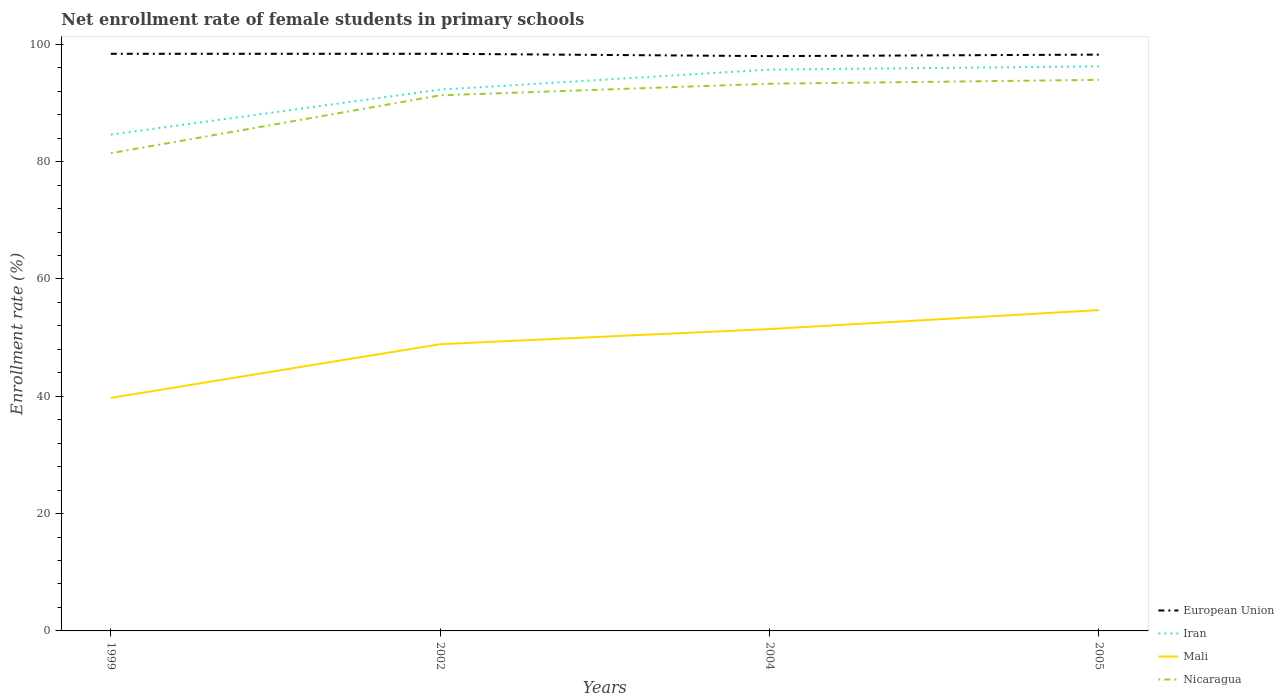Across all years, what is the maximum net enrollment rate of female students in primary schools in Iran?
Ensure brevity in your answer.  84.6. In which year was the net enrollment rate of female students in primary schools in Nicaragua maximum?
Make the answer very short. 1999. What is the total net enrollment rate of female students in primary schools in Iran in the graph?
Keep it short and to the point. -0.55. What is the difference between the highest and the second highest net enrollment rate of female students in primary schools in Iran?
Your answer should be compact. 11.64. What is the difference between the highest and the lowest net enrollment rate of female students in primary schools in European Union?
Provide a short and direct response. 2. Is the net enrollment rate of female students in primary schools in Nicaragua strictly greater than the net enrollment rate of female students in primary schools in European Union over the years?
Give a very brief answer. Yes. How many lines are there?
Ensure brevity in your answer.  4. Are the values on the major ticks of Y-axis written in scientific E-notation?
Your answer should be compact. No. Does the graph contain any zero values?
Your answer should be very brief. No. Does the graph contain grids?
Your answer should be compact. No. How many legend labels are there?
Make the answer very short. 4. What is the title of the graph?
Ensure brevity in your answer.  Net enrollment rate of female students in primary schools. Does "Panama" appear as one of the legend labels in the graph?
Make the answer very short. No. What is the label or title of the X-axis?
Keep it short and to the point. Years. What is the label or title of the Y-axis?
Your response must be concise. Enrollment rate (%). What is the Enrollment rate (%) of European Union in 1999?
Your answer should be compact. 98.38. What is the Enrollment rate (%) of Iran in 1999?
Provide a short and direct response. 84.6. What is the Enrollment rate (%) of Mali in 1999?
Ensure brevity in your answer.  39.72. What is the Enrollment rate (%) in Nicaragua in 1999?
Offer a very short reply. 81.43. What is the Enrollment rate (%) of European Union in 2002?
Provide a short and direct response. 98.38. What is the Enrollment rate (%) of Iran in 2002?
Keep it short and to the point. 92.27. What is the Enrollment rate (%) in Mali in 2002?
Give a very brief answer. 48.87. What is the Enrollment rate (%) in Nicaragua in 2002?
Make the answer very short. 91.3. What is the Enrollment rate (%) of European Union in 2004?
Your response must be concise. 97.98. What is the Enrollment rate (%) in Iran in 2004?
Your answer should be very brief. 95.68. What is the Enrollment rate (%) in Mali in 2004?
Your response must be concise. 51.46. What is the Enrollment rate (%) in Nicaragua in 2004?
Keep it short and to the point. 93.28. What is the Enrollment rate (%) in European Union in 2005?
Your answer should be very brief. 98.24. What is the Enrollment rate (%) in Iran in 2005?
Offer a very short reply. 96.24. What is the Enrollment rate (%) of Mali in 2005?
Make the answer very short. 54.69. What is the Enrollment rate (%) of Nicaragua in 2005?
Keep it short and to the point. 93.94. Across all years, what is the maximum Enrollment rate (%) of European Union?
Offer a terse response. 98.38. Across all years, what is the maximum Enrollment rate (%) in Iran?
Your answer should be compact. 96.24. Across all years, what is the maximum Enrollment rate (%) in Mali?
Your answer should be very brief. 54.69. Across all years, what is the maximum Enrollment rate (%) of Nicaragua?
Offer a terse response. 93.94. Across all years, what is the minimum Enrollment rate (%) in European Union?
Provide a succinct answer. 97.98. Across all years, what is the minimum Enrollment rate (%) of Iran?
Keep it short and to the point. 84.6. Across all years, what is the minimum Enrollment rate (%) of Mali?
Your answer should be very brief. 39.72. Across all years, what is the minimum Enrollment rate (%) of Nicaragua?
Offer a terse response. 81.43. What is the total Enrollment rate (%) in European Union in the graph?
Offer a very short reply. 392.97. What is the total Enrollment rate (%) of Iran in the graph?
Your answer should be compact. 368.79. What is the total Enrollment rate (%) of Mali in the graph?
Provide a succinct answer. 194.74. What is the total Enrollment rate (%) in Nicaragua in the graph?
Your response must be concise. 359.94. What is the difference between the Enrollment rate (%) of European Union in 1999 and that in 2002?
Your response must be concise. -0. What is the difference between the Enrollment rate (%) of Iran in 1999 and that in 2002?
Give a very brief answer. -7.67. What is the difference between the Enrollment rate (%) in Mali in 1999 and that in 2002?
Provide a short and direct response. -9.15. What is the difference between the Enrollment rate (%) in Nicaragua in 1999 and that in 2002?
Make the answer very short. -9.86. What is the difference between the Enrollment rate (%) of European Union in 1999 and that in 2004?
Offer a terse response. 0.4. What is the difference between the Enrollment rate (%) in Iran in 1999 and that in 2004?
Your answer should be very brief. -11.08. What is the difference between the Enrollment rate (%) in Mali in 1999 and that in 2004?
Provide a short and direct response. -11.74. What is the difference between the Enrollment rate (%) in Nicaragua in 1999 and that in 2004?
Ensure brevity in your answer.  -11.84. What is the difference between the Enrollment rate (%) in European Union in 1999 and that in 2005?
Keep it short and to the point. 0.14. What is the difference between the Enrollment rate (%) of Iran in 1999 and that in 2005?
Your answer should be very brief. -11.64. What is the difference between the Enrollment rate (%) of Mali in 1999 and that in 2005?
Offer a very short reply. -14.97. What is the difference between the Enrollment rate (%) of Nicaragua in 1999 and that in 2005?
Your answer should be compact. -12.5. What is the difference between the Enrollment rate (%) of European Union in 2002 and that in 2004?
Keep it short and to the point. 0.4. What is the difference between the Enrollment rate (%) of Iran in 2002 and that in 2004?
Make the answer very short. -3.41. What is the difference between the Enrollment rate (%) of Mali in 2002 and that in 2004?
Offer a very short reply. -2.59. What is the difference between the Enrollment rate (%) of Nicaragua in 2002 and that in 2004?
Offer a terse response. -1.98. What is the difference between the Enrollment rate (%) of European Union in 2002 and that in 2005?
Your answer should be compact. 0.14. What is the difference between the Enrollment rate (%) of Iran in 2002 and that in 2005?
Offer a very short reply. -3.97. What is the difference between the Enrollment rate (%) in Mali in 2002 and that in 2005?
Your response must be concise. -5.81. What is the difference between the Enrollment rate (%) of Nicaragua in 2002 and that in 2005?
Provide a short and direct response. -2.64. What is the difference between the Enrollment rate (%) in European Union in 2004 and that in 2005?
Offer a terse response. -0.26. What is the difference between the Enrollment rate (%) in Iran in 2004 and that in 2005?
Keep it short and to the point. -0.55. What is the difference between the Enrollment rate (%) of Mali in 2004 and that in 2005?
Offer a very short reply. -3.23. What is the difference between the Enrollment rate (%) of Nicaragua in 2004 and that in 2005?
Provide a succinct answer. -0.66. What is the difference between the Enrollment rate (%) of European Union in 1999 and the Enrollment rate (%) of Iran in 2002?
Provide a short and direct response. 6.11. What is the difference between the Enrollment rate (%) in European Union in 1999 and the Enrollment rate (%) in Mali in 2002?
Your answer should be very brief. 49.5. What is the difference between the Enrollment rate (%) in European Union in 1999 and the Enrollment rate (%) in Nicaragua in 2002?
Ensure brevity in your answer.  7.08. What is the difference between the Enrollment rate (%) in Iran in 1999 and the Enrollment rate (%) in Mali in 2002?
Keep it short and to the point. 35.73. What is the difference between the Enrollment rate (%) in Iran in 1999 and the Enrollment rate (%) in Nicaragua in 2002?
Your response must be concise. -6.7. What is the difference between the Enrollment rate (%) in Mali in 1999 and the Enrollment rate (%) in Nicaragua in 2002?
Offer a terse response. -51.58. What is the difference between the Enrollment rate (%) of European Union in 1999 and the Enrollment rate (%) of Iran in 2004?
Provide a short and direct response. 2.69. What is the difference between the Enrollment rate (%) of European Union in 1999 and the Enrollment rate (%) of Mali in 2004?
Provide a succinct answer. 46.92. What is the difference between the Enrollment rate (%) of European Union in 1999 and the Enrollment rate (%) of Nicaragua in 2004?
Your response must be concise. 5.1. What is the difference between the Enrollment rate (%) in Iran in 1999 and the Enrollment rate (%) in Mali in 2004?
Give a very brief answer. 33.14. What is the difference between the Enrollment rate (%) in Iran in 1999 and the Enrollment rate (%) in Nicaragua in 2004?
Your answer should be compact. -8.67. What is the difference between the Enrollment rate (%) of Mali in 1999 and the Enrollment rate (%) of Nicaragua in 2004?
Your answer should be very brief. -53.56. What is the difference between the Enrollment rate (%) of European Union in 1999 and the Enrollment rate (%) of Iran in 2005?
Your answer should be very brief. 2.14. What is the difference between the Enrollment rate (%) of European Union in 1999 and the Enrollment rate (%) of Mali in 2005?
Make the answer very short. 43.69. What is the difference between the Enrollment rate (%) of European Union in 1999 and the Enrollment rate (%) of Nicaragua in 2005?
Provide a succinct answer. 4.44. What is the difference between the Enrollment rate (%) in Iran in 1999 and the Enrollment rate (%) in Mali in 2005?
Make the answer very short. 29.91. What is the difference between the Enrollment rate (%) in Iran in 1999 and the Enrollment rate (%) in Nicaragua in 2005?
Ensure brevity in your answer.  -9.33. What is the difference between the Enrollment rate (%) of Mali in 1999 and the Enrollment rate (%) of Nicaragua in 2005?
Provide a short and direct response. -54.22. What is the difference between the Enrollment rate (%) of European Union in 2002 and the Enrollment rate (%) of Iran in 2004?
Offer a very short reply. 2.7. What is the difference between the Enrollment rate (%) of European Union in 2002 and the Enrollment rate (%) of Mali in 2004?
Provide a succinct answer. 46.92. What is the difference between the Enrollment rate (%) in European Union in 2002 and the Enrollment rate (%) in Nicaragua in 2004?
Your response must be concise. 5.1. What is the difference between the Enrollment rate (%) of Iran in 2002 and the Enrollment rate (%) of Mali in 2004?
Keep it short and to the point. 40.81. What is the difference between the Enrollment rate (%) of Iran in 2002 and the Enrollment rate (%) of Nicaragua in 2004?
Give a very brief answer. -1.01. What is the difference between the Enrollment rate (%) in Mali in 2002 and the Enrollment rate (%) in Nicaragua in 2004?
Your answer should be very brief. -44.4. What is the difference between the Enrollment rate (%) in European Union in 2002 and the Enrollment rate (%) in Iran in 2005?
Provide a short and direct response. 2.14. What is the difference between the Enrollment rate (%) of European Union in 2002 and the Enrollment rate (%) of Mali in 2005?
Make the answer very short. 43.69. What is the difference between the Enrollment rate (%) in European Union in 2002 and the Enrollment rate (%) in Nicaragua in 2005?
Ensure brevity in your answer.  4.44. What is the difference between the Enrollment rate (%) in Iran in 2002 and the Enrollment rate (%) in Mali in 2005?
Your answer should be compact. 37.58. What is the difference between the Enrollment rate (%) of Iran in 2002 and the Enrollment rate (%) of Nicaragua in 2005?
Your response must be concise. -1.67. What is the difference between the Enrollment rate (%) in Mali in 2002 and the Enrollment rate (%) in Nicaragua in 2005?
Give a very brief answer. -45.06. What is the difference between the Enrollment rate (%) in European Union in 2004 and the Enrollment rate (%) in Iran in 2005?
Your response must be concise. 1.74. What is the difference between the Enrollment rate (%) in European Union in 2004 and the Enrollment rate (%) in Mali in 2005?
Your response must be concise. 43.29. What is the difference between the Enrollment rate (%) in European Union in 2004 and the Enrollment rate (%) in Nicaragua in 2005?
Provide a short and direct response. 4.05. What is the difference between the Enrollment rate (%) of Iran in 2004 and the Enrollment rate (%) of Mali in 2005?
Provide a short and direct response. 41. What is the difference between the Enrollment rate (%) of Iran in 2004 and the Enrollment rate (%) of Nicaragua in 2005?
Your answer should be compact. 1.75. What is the difference between the Enrollment rate (%) in Mali in 2004 and the Enrollment rate (%) in Nicaragua in 2005?
Give a very brief answer. -42.48. What is the average Enrollment rate (%) in European Union per year?
Provide a short and direct response. 98.24. What is the average Enrollment rate (%) of Iran per year?
Your answer should be compact. 92.2. What is the average Enrollment rate (%) of Mali per year?
Provide a short and direct response. 48.68. What is the average Enrollment rate (%) of Nicaragua per year?
Your answer should be compact. 89.99. In the year 1999, what is the difference between the Enrollment rate (%) in European Union and Enrollment rate (%) in Iran?
Keep it short and to the point. 13.78. In the year 1999, what is the difference between the Enrollment rate (%) in European Union and Enrollment rate (%) in Mali?
Make the answer very short. 58.66. In the year 1999, what is the difference between the Enrollment rate (%) of European Union and Enrollment rate (%) of Nicaragua?
Provide a short and direct response. 16.94. In the year 1999, what is the difference between the Enrollment rate (%) in Iran and Enrollment rate (%) in Mali?
Your response must be concise. 44.88. In the year 1999, what is the difference between the Enrollment rate (%) in Iran and Enrollment rate (%) in Nicaragua?
Offer a very short reply. 3.17. In the year 1999, what is the difference between the Enrollment rate (%) of Mali and Enrollment rate (%) of Nicaragua?
Offer a terse response. -41.71. In the year 2002, what is the difference between the Enrollment rate (%) in European Union and Enrollment rate (%) in Iran?
Give a very brief answer. 6.11. In the year 2002, what is the difference between the Enrollment rate (%) in European Union and Enrollment rate (%) in Mali?
Ensure brevity in your answer.  49.51. In the year 2002, what is the difference between the Enrollment rate (%) of European Union and Enrollment rate (%) of Nicaragua?
Offer a terse response. 7.08. In the year 2002, what is the difference between the Enrollment rate (%) of Iran and Enrollment rate (%) of Mali?
Give a very brief answer. 43.4. In the year 2002, what is the difference between the Enrollment rate (%) in Iran and Enrollment rate (%) in Nicaragua?
Ensure brevity in your answer.  0.97. In the year 2002, what is the difference between the Enrollment rate (%) of Mali and Enrollment rate (%) of Nicaragua?
Provide a short and direct response. -42.43. In the year 2004, what is the difference between the Enrollment rate (%) in European Union and Enrollment rate (%) in Iran?
Offer a very short reply. 2.3. In the year 2004, what is the difference between the Enrollment rate (%) of European Union and Enrollment rate (%) of Mali?
Offer a terse response. 46.52. In the year 2004, what is the difference between the Enrollment rate (%) in European Union and Enrollment rate (%) in Nicaragua?
Give a very brief answer. 4.7. In the year 2004, what is the difference between the Enrollment rate (%) in Iran and Enrollment rate (%) in Mali?
Your answer should be compact. 44.22. In the year 2004, what is the difference between the Enrollment rate (%) of Iran and Enrollment rate (%) of Nicaragua?
Ensure brevity in your answer.  2.41. In the year 2004, what is the difference between the Enrollment rate (%) in Mali and Enrollment rate (%) in Nicaragua?
Give a very brief answer. -41.82. In the year 2005, what is the difference between the Enrollment rate (%) of European Union and Enrollment rate (%) of Iran?
Give a very brief answer. 2. In the year 2005, what is the difference between the Enrollment rate (%) of European Union and Enrollment rate (%) of Mali?
Ensure brevity in your answer.  43.55. In the year 2005, what is the difference between the Enrollment rate (%) of European Union and Enrollment rate (%) of Nicaragua?
Your response must be concise. 4.3. In the year 2005, what is the difference between the Enrollment rate (%) in Iran and Enrollment rate (%) in Mali?
Make the answer very short. 41.55. In the year 2005, what is the difference between the Enrollment rate (%) of Iran and Enrollment rate (%) of Nicaragua?
Make the answer very short. 2.3. In the year 2005, what is the difference between the Enrollment rate (%) in Mali and Enrollment rate (%) in Nicaragua?
Keep it short and to the point. -39.25. What is the ratio of the Enrollment rate (%) in Iran in 1999 to that in 2002?
Your response must be concise. 0.92. What is the ratio of the Enrollment rate (%) of Mali in 1999 to that in 2002?
Your answer should be compact. 0.81. What is the ratio of the Enrollment rate (%) in Nicaragua in 1999 to that in 2002?
Your answer should be compact. 0.89. What is the ratio of the Enrollment rate (%) of European Union in 1999 to that in 2004?
Keep it short and to the point. 1. What is the ratio of the Enrollment rate (%) in Iran in 1999 to that in 2004?
Provide a succinct answer. 0.88. What is the ratio of the Enrollment rate (%) of Mali in 1999 to that in 2004?
Offer a very short reply. 0.77. What is the ratio of the Enrollment rate (%) in Nicaragua in 1999 to that in 2004?
Your response must be concise. 0.87. What is the ratio of the Enrollment rate (%) in European Union in 1999 to that in 2005?
Offer a very short reply. 1. What is the ratio of the Enrollment rate (%) in Iran in 1999 to that in 2005?
Offer a terse response. 0.88. What is the ratio of the Enrollment rate (%) in Mali in 1999 to that in 2005?
Offer a terse response. 0.73. What is the ratio of the Enrollment rate (%) of Nicaragua in 1999 to that in 2005?
Keep it short and to the point. 0.87. What is the ratio of the Enrollment rate (%) of Iran in 2002 to that in 2004?
Offer a very short reply. 0.96. What is the ratio of the Enrollment rate (%) in Mali in 2002 to that in 2004?
Make the answer very short. 0.95. What is the ratio of the Enrollment rate (%) of Nicaragua in 2002 to that in 2004?
Ensure brevity in your answer.  0.98. What is the ratio of the Enrollment rate (%) of European Union in 2002 to that in 2005?
Offer a very short reply. 1. What is the ratio of the Enrollment rate (%) of Iran in 2002 to that in 2005?
Your answer should be compact. 0.96. What is the ratio of the Enrollment rate (%) of Mali in 2002 to that in 2005?
Give a very brief answer. 0.89. What is the ratio of the Enrollment rate (%) in Nicaragua in 2002 to that in 2005?
Provide a short and direct response. 0.97. What is the ratio of the Enrollment rate (%) of European Union in 2004 to that in 2005?
Ensure brevity in your answer.  1. What is the ratio of the Enrollment rate (%) of Iran in 2004 to that in 2005?
Offer a terse response. 0.99. What is the ratio of the Enrollment rate (%) in Mali in 2004 to that in 2005?
Keep it short and to the point. 0.94. What is the ratio of the Enrollment rate (%) of Nicaragua in 2004 to that in 2005?
Keep it short and to the point. 0.99. What is the difference between the highest and the second highest Enrollment rate (%) of European Union?
Offer a terse response. 0. What is the difference between the highest and the second highest Enrollment rate (%) in Iran?
Offer a very short reply. 0.55. What is the difference between the highest and the second highest Enrollment rate (%) of Mali?
Your answer should be compact. 3.23. What is the difference between the highest and the second highest Enrollment rate (%) of Nicaragua?
Give a very brief answer. 0.66. What is the difference between the highest and the lowest Enrollment rate (%) of European Union?
Provide a short and direct response. 0.4. What is the difference between the highest and the lowest Enrollment rate (%) in Iran?
Your answer should be compact. 11.64. What is the difference between the highest and the lowest Enrollment rate (%) in Mali?
Offer a terse response. 14.97. What is the difference between the highest and the lowest Enrollment rate (%) of Nicaragua?
Offer a terse response. 12.5. 